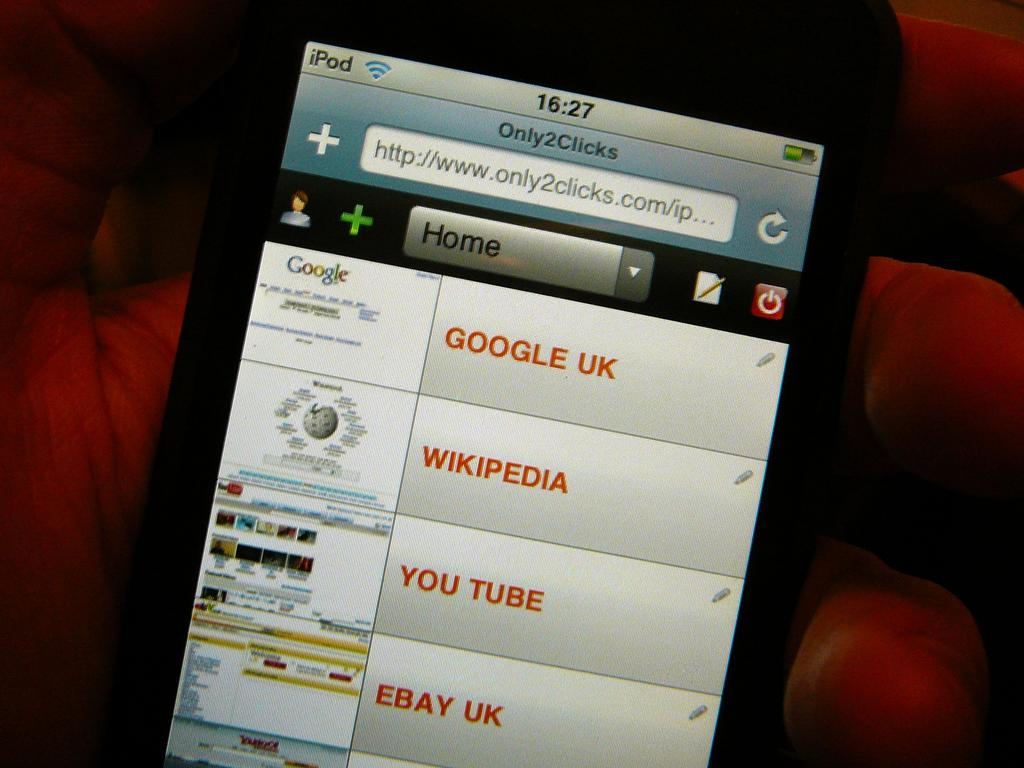<image>
Summarize the visual content of the image. A screen with options like "Google UK" and "Wikipedia" on it. 